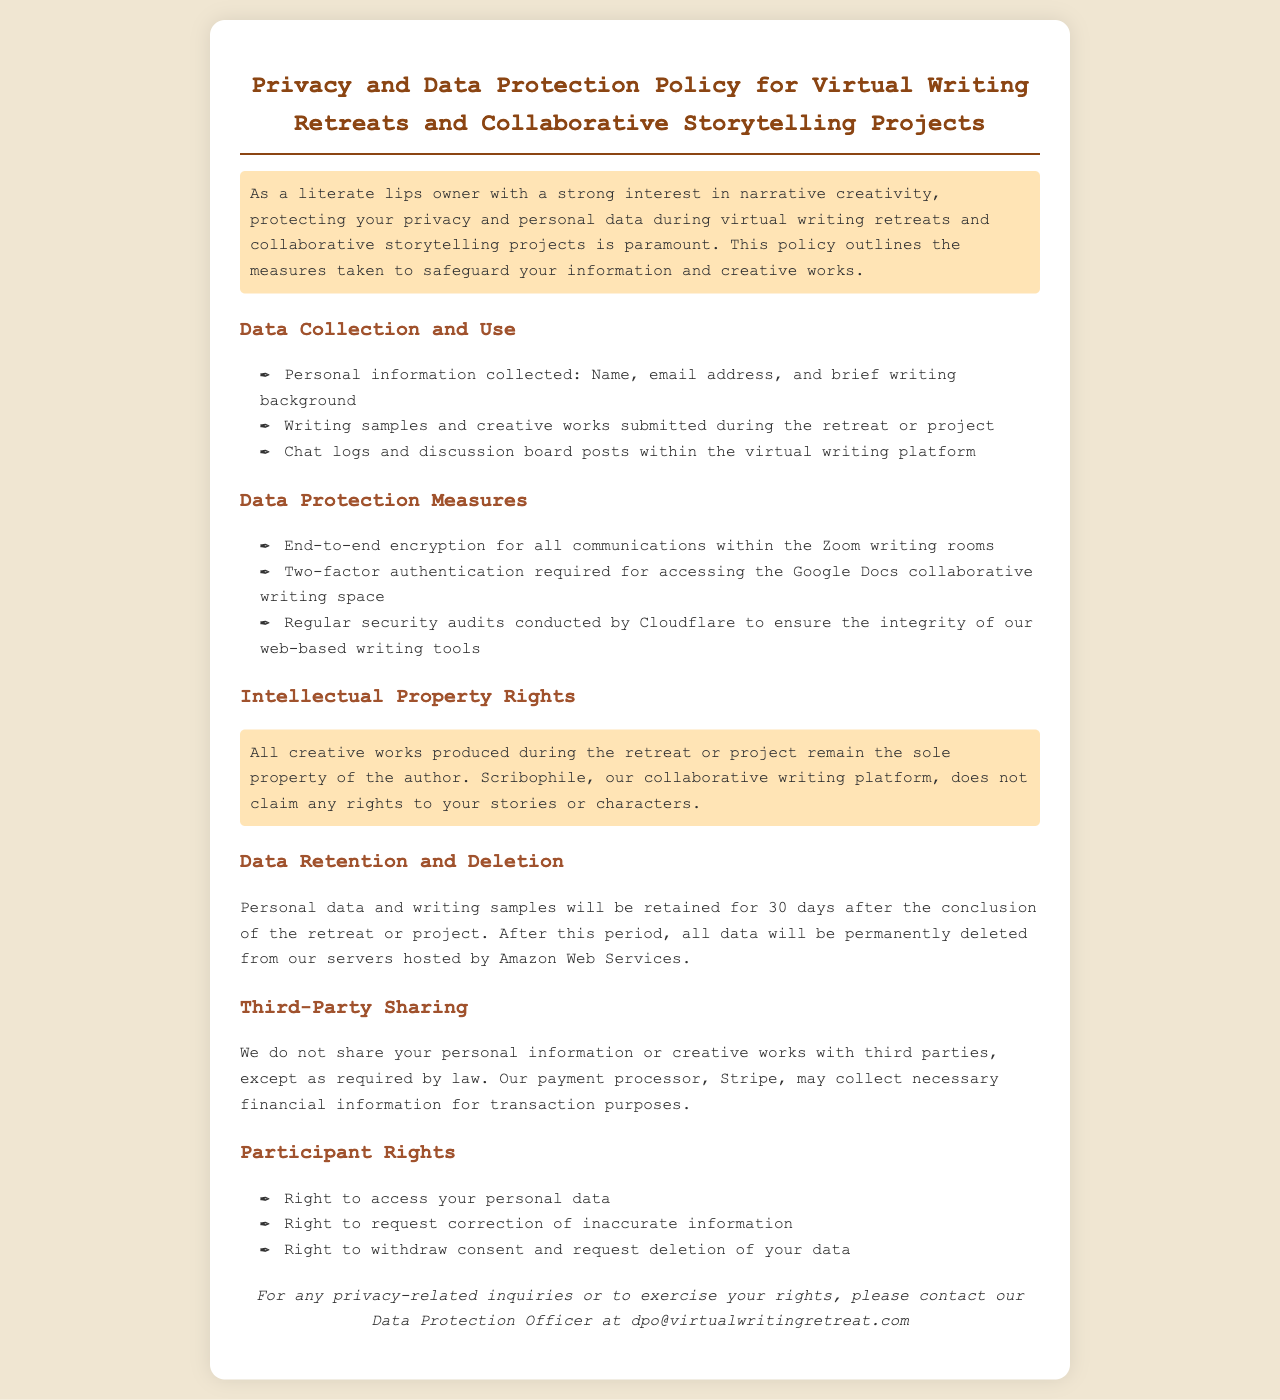what personal information is collected? The document specifies that personal information collected includes name, email address, and brief writing background.
Answer: Name, email address, and brief writing background how long will personal data be retained after the project? The document states that personal data and writing samples will be retained for a specific period post-project.
Answer: 30 days what is required for accessing the Google Docs collaborative writing space? According to the document, a specific security measure is mandated for accessing the collaborative space.
Answer: Two-factor authentication who is the Data Protection Officer contact? The document provides a specific contact email for privacy-related inquiries.
Answer: dpo@virtualwritingretreat.com what platform is used for collaborative writing? The document mentions a specific platform used for collaboration during the retreats.
Answer: Scribophile what is the status of intellectual property rights? The document clarifies the ownership of creative works produced during the retreat.
Answer: Sole property of the author how often are security audits conducted? The document indicates a frequency of security assessments for the web-based writing tools.
Answer: Regularly is personal information shared with third parties? The document addresses the information sharing policy regarding third parties.
Answer: No 